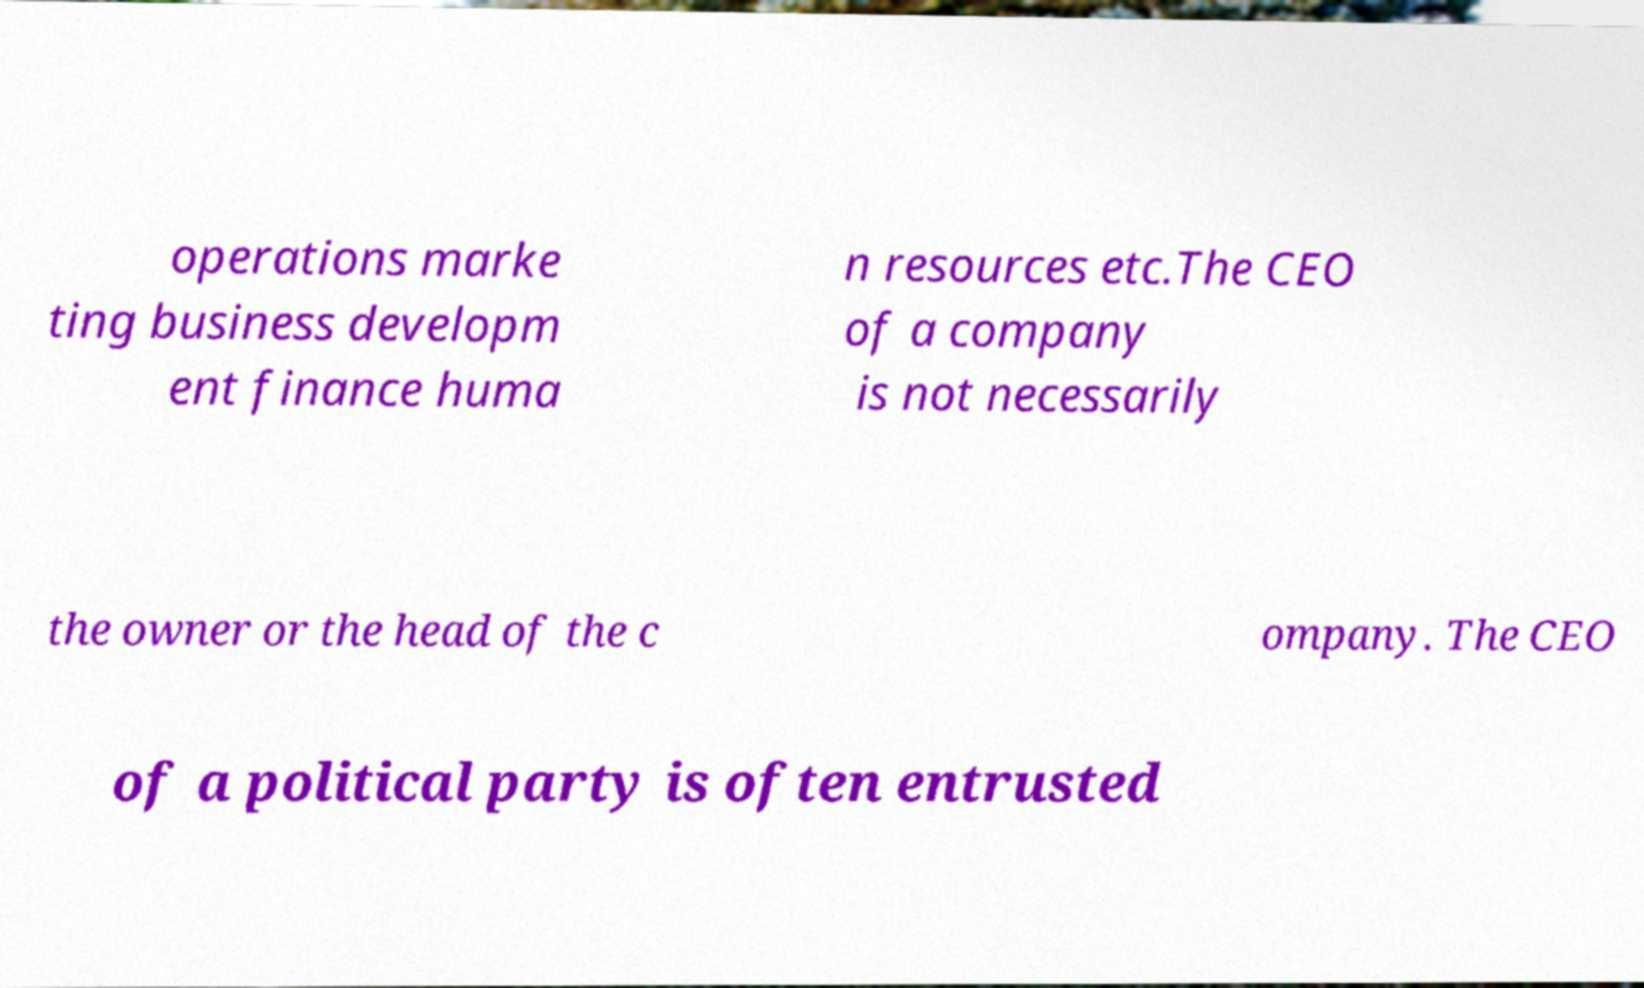Please identify and transcribe the text found in this image. operations marke ting business developm ent finance huma n resources etc.The CEO of a company is not necessarily the owner or the head of the c ompany. The CEO of a political party is often entrusted 